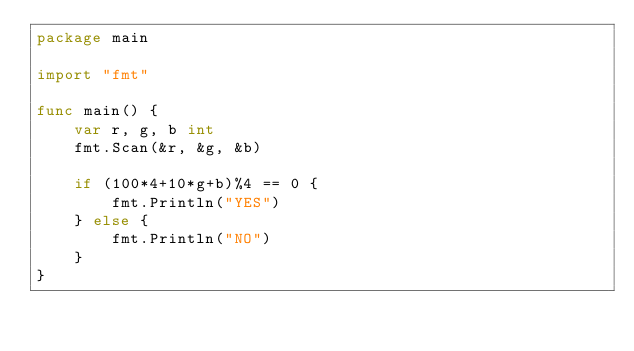<code> <loc_0><loc_0><loc_500><loc_500><_Go_>package main

import "fmt"

func main() {
	var r, g, b int
	fmt.Scan(&r, &g, &b)

	if (100*4+10*g+b)%4 == 0 {
		fmt.Println("YES")
	} else {
		fmt.Println("NO")
	}
}
</code> 